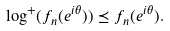<formula> <loc_0><loc_0><loc_500><loc_500>\log ^ { + } ( f _ { n } ( e ^ { i \theta } ) ) \preceq f _ { n } ( e ^ { i \theta } ) .</formula> 